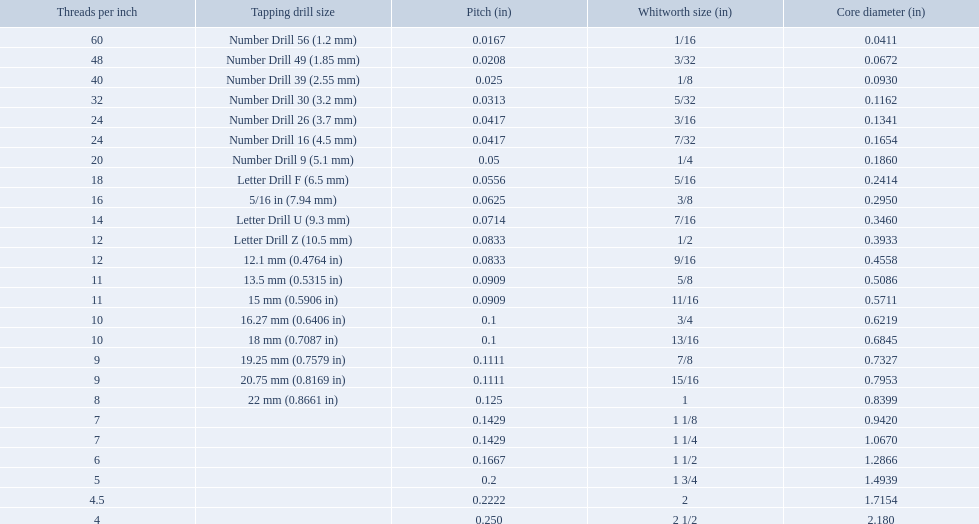A 1/16 whitworth has a core diameter of? 0.0411. Which whiteworth size has the same pitch as a 1/2? 9/16. 3/16 whiteworth has the same number of threads as? 7/32. 